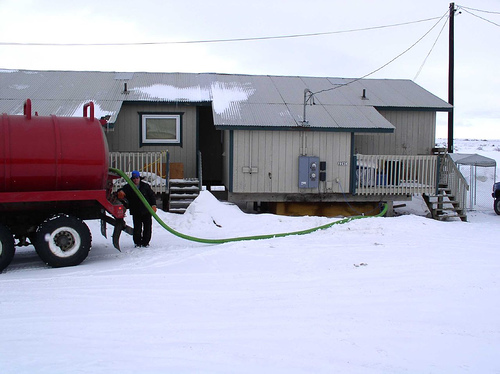<image>
Is the truck in front of the man? No. The truck is not in front of the man. The spatial positioning shows a different relationship between these objects. 